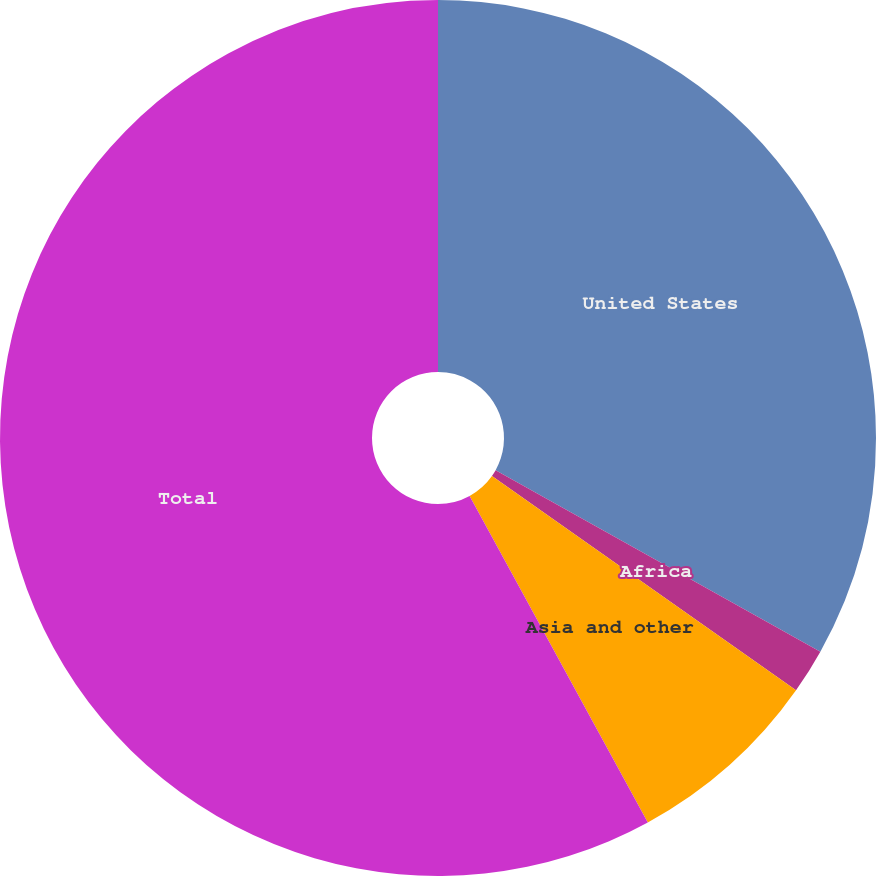<chart> <loc_0><loc_0><loc_500><loc_500><pie_chart><fcel>United States<fcel>Africa<fcel>Asia and other<fcel>Total<nl><fcel>33.11%<fcel>1.66%<fcel>7.28%<fcel>57.95%<nl></chart> 